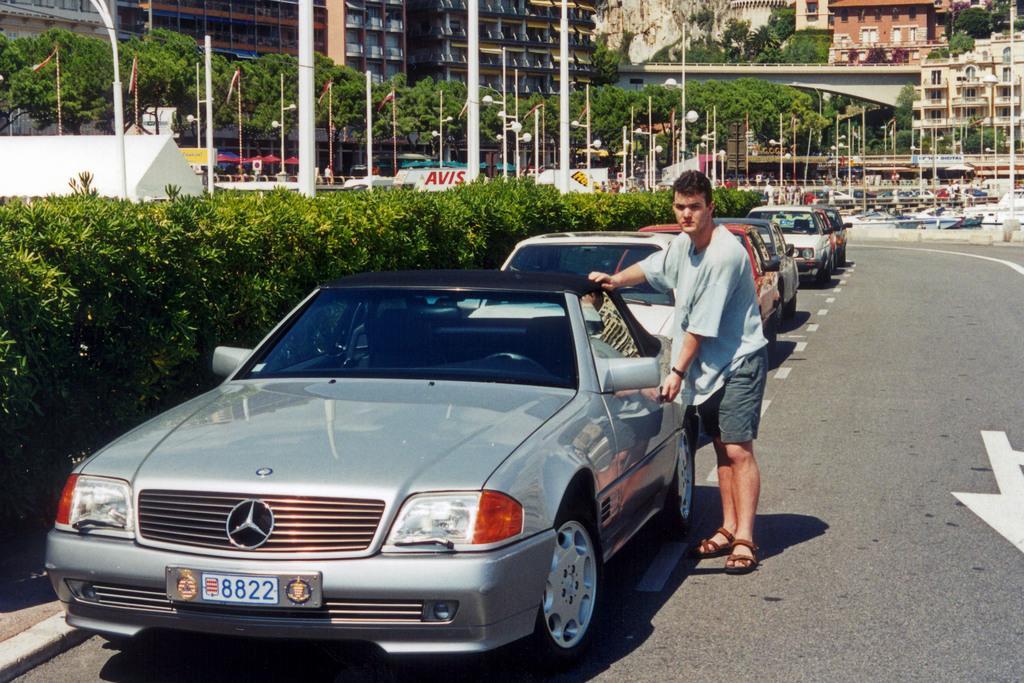Could you give a brief overview of what you see in this image? In this image we can see a person standing on the ground ,a group of cars are parked on the ground. On the left side, we can see group of plants, poles, flags. In the background, we can see a boat, a group of buildings, trees and a bridge. 